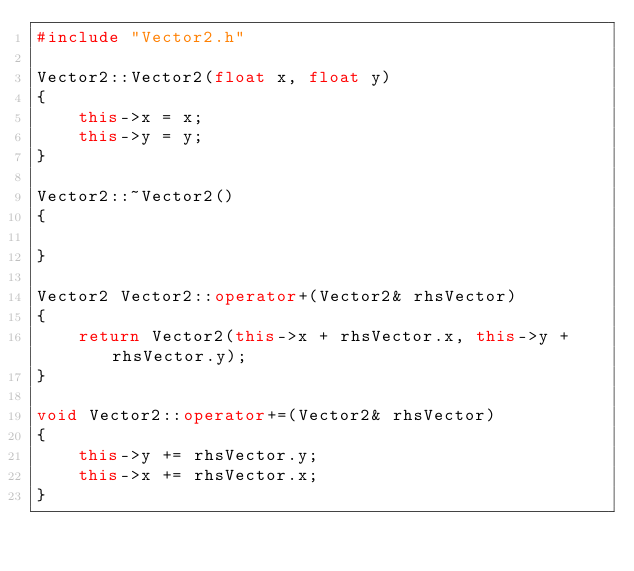<code> <loc_0><loc_0><loc_500><loc_500><_C++_>#include "Vector2.h"

Vector2::Vector2(float x, float y)
{
	this->x = x;
	this->y = y;
}

Vector2::~Vector2()
{

}

Vector2 Vector2::operator+(Vector2& rhsVector)
{
	return Vector2(this->x + rhsVector.x, this->y + rhsVector.y);
}

void Vector2::operator+=(Vector2& rhsVector)
{
	this->y += rhsVector.y;
	this->x += rhsVector.x;
}</code> 